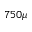<formula> <loc_0><loc_0><loc_500><loc_500>7 5 0 \mu</formula> 